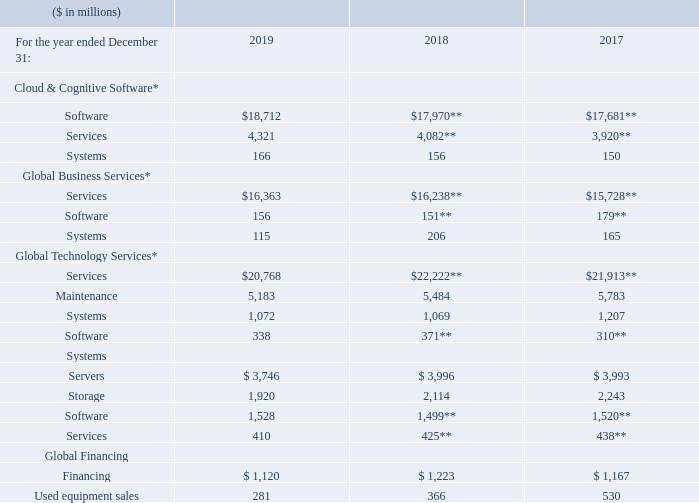* Recast to conform to 2019 presentation.
** Reclassified to conform to 2019 presentation. Refer to “Basis of
Presentation” in note A, “Significant Accounting Policies,” for
additional information.
The following table presents external revenue for similar classes of products or services within the company’s reportable segments. Client solutions often include IBM software and systems and other suppliers’ products if the client solution requires it.
For each of the segments that include services, Software-as-a-Service, consulting, education, training and other product-related services are included as services. For each of these segments, software includes product license charges and ongoing subscriptions.
What is included in Client solutions? Client solutions often include ibm software and systems and other suppliers’ products if the client solution requires it. What is included in Services? For each of the segments that include services, software-as-a-service, consulting, education, training and other product-related services are included as services. What is included in Software? For each of these segments, software includes product license charges and ongoing subscriptions. What is the average of Financing under Global Financing?
Answer scale should be: million. (1,120+1,223+1,167 ) / 3
Answer: 1170. What is the average of Used equipment sales?
Answer scale should be: million. (281+366+530) / 3
Answer: 392.33. What is the increase/ (decrease) in Used equipment sales from 2018 to 2019
Answer scale should be: million. 281-366 
Answer: -85. 